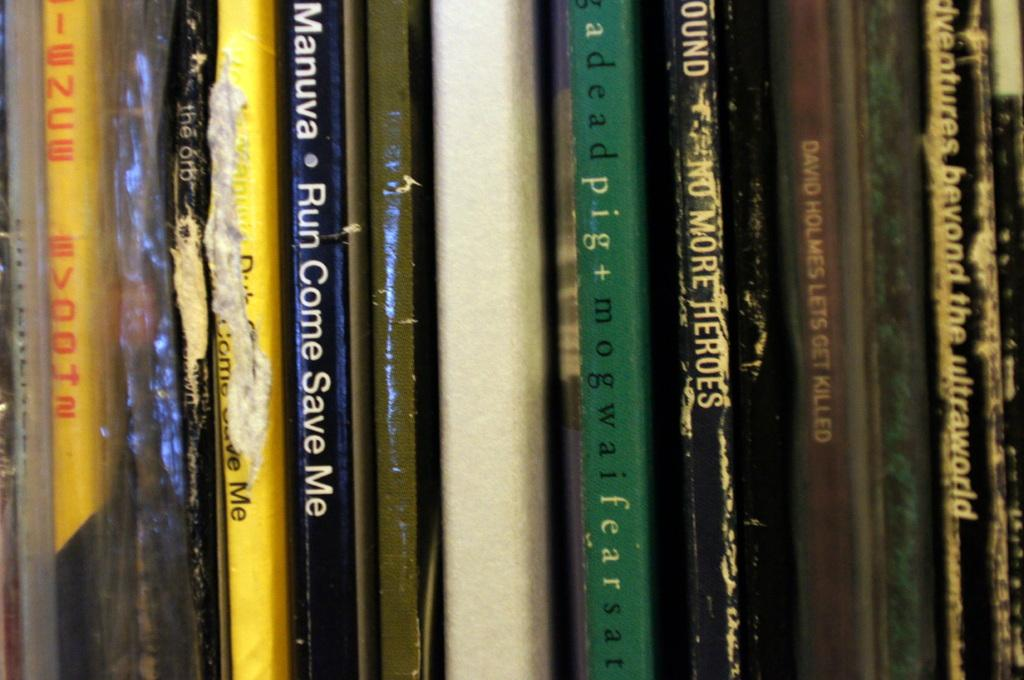<image>
Share a concise interpretation of the image provided. A book titled " Run Come Save Me" by Manuva, 